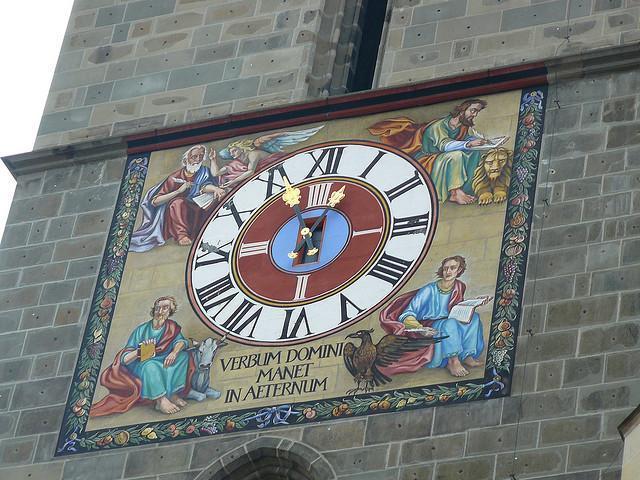What language are the words on the clock written in?
Choose the correct response and explain in the format: 'Answer: answer
Rationale: rationale.'
Options: Greek, hebrew, latin, spanish. Answer: latin.
Rationale: This language is latin which was the common language of the catholic church many years ago. 